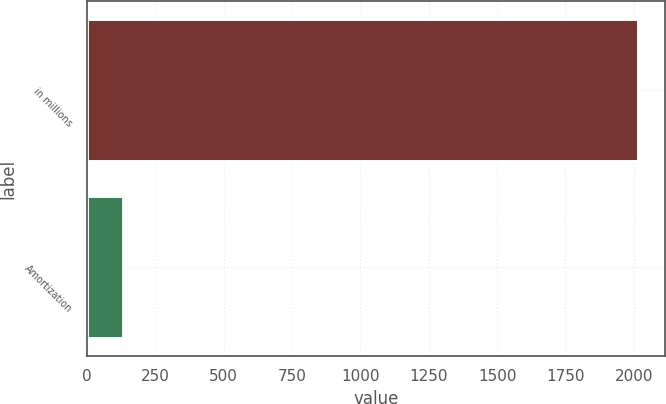Convert chart. <chart><loc_0><loc_0><loc_500><loc_500><bar_chart><fcel>in millions<fcel>Amortization<nl><fcel>2015<fcel>132<nl></chart> 